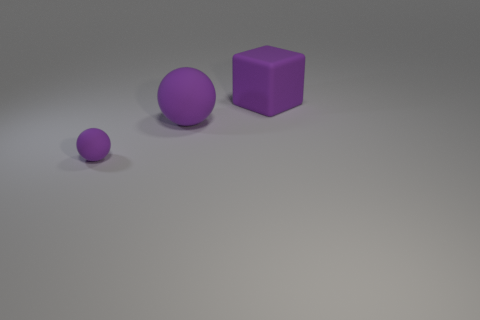Is there anything in the image that gives us a clue about the scale or actual size of these objects? Without a point of reference or known object to determine scale, the actual size of these objects remains ambiguous. They could vary from miniature models to larger playground-size objects. 